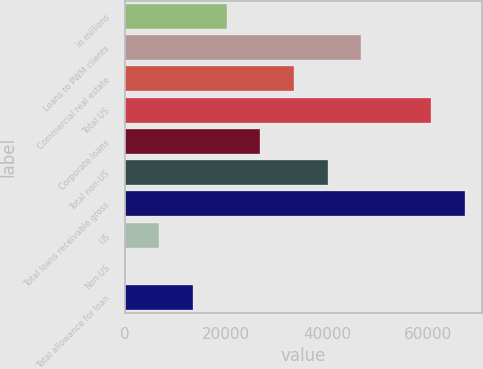Convert chart. <chart><loc_0><loc_0><loc_500><loc_500><bar_chart><fcel>in millions<fcel>Loans to PWM clients<fcel>Commercial real estate<fcel>Total US<fcel>Corporate loans<fcel>Total non-US<fcel>Total loans receivable gross<fcel>US<fcel>Non-US<fcel>Total allowance for loan<nl><fcel>20160.1<fcel>46774.9<fcel>33467.5<fcel>60582<fcel>26813.8<fcel>40121.2<fcel>67235.7<fcel>6852.7<fcel>199<fcel>13506.4<nl></chart> 